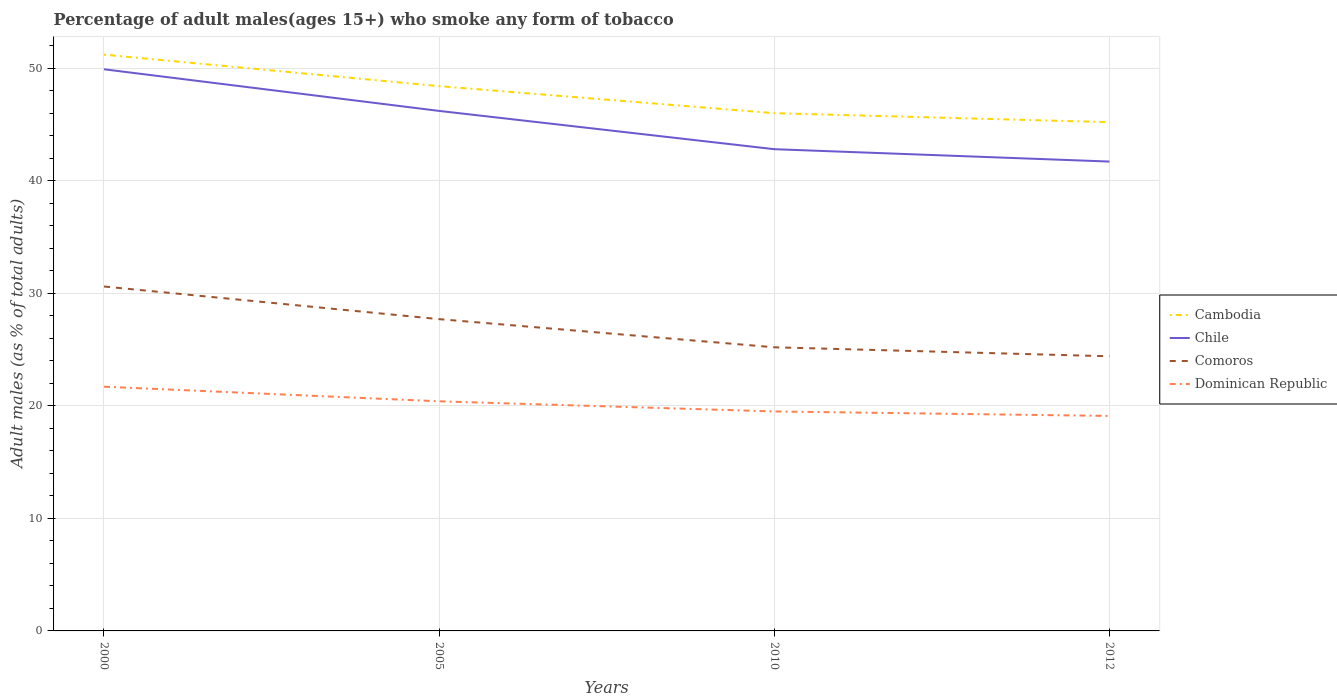How many different coloured lines are there?
Provide a succinct answer. 4. Across all years, what is the maximum percentage of adult males who smoke in Cambodia?
Offer a very short reply. 45.2. In which year was the percentage of adult males who smoke in Dominican Republic maximum?
Provide a succinct answer. 2012. What is the total percentage of adult males who smoke in Comoros in the graph?
Make the answer very short. 2.9. What is the difference between the highest and the second highest percentage of adult males who smoke in Cambodia?
Your response must be concise. 6. Is the percentage of adult males who smoke in Comoros strictly greater than the percentage of adult males who smoke in Cambodia over the years?
Provide a succinct answer. Yes. How many lines are there?
Your answer should be very brief. 4. How many years are there in the graph?
Your response must be concise. 4. What is the difference between two consecutive major ticks on the Y-axis?
Your answer should be compact. 10. Does the graph contain any zero values?
Your answer should be compact. No. Where does the legend appear in the graph?
Your answer should be compact. Center right. How are the legend labels stacked?
Keep it short and to the point. Vertical. What is the title of the graph?
Your answer should be very brief. Percentage of adult males(ages 15+) who smoke any form of tobacco. What is the label or title of the Y-axis?
Give a very brief answer. Adult males (as % of total adults). What is the Adult males (as % of total adults) of Cambodia in 2000?
Keep it short and to the point. 51.2. What is the Adult males (as % of total adults) of Chile in 2000?
Make the answer very short. 49.9. What is the Adult males (as % of total adults) of Comoros in 2000?
Provide a short and direct response. 30.6. What is the Adult males (as % of total adults) of Dominican Republic in 2000?
Make the answer very short. 21.7. What is the Adult males (as % of total adults) in Cambodia in 2005?
Your answer should be very brief. 48.4. What is the Adult males (as % of total adults) of Chile in 2005?
Offer a very short reply. 46.2. What is the Adult males (as % of total adults) in Comoros in 2005?
Provide a short and direct response. 27.7. What is the Adult males (as % of total adults) in Dominican Republic in 2005?
Your answer should be very brief. 20.4. What is the Adult males (as % of total adults) of Chile in 2010?
Give a very brief answer. 42.8. What is the Adult males (as % of total adults) in Comoros in 2010?
Provide a succinct answer. 25.2. What is the Adult males (as % of total adults) of Cambodia in 2012?
Offer a very short reply. 45.2. What is the Adult males (as % of total adults) of Chile in 2012?
Keep it short and to the point. 41.7. What is the Adult males (as % of total adults) in Comoros in 2012?
Offer a terse response. 24.4. Across all years, what is the maximum Adult males (as % of total adults) in Cambodia?
Provide a short and direct response. 51.2. Across all years, what is the maximum Adult males (as % of total adults) of Chile?
Give a very brief answer. 49.9. Across all years, what is the maximum Adult males (as % of total adults) in Comoros?
Give a very brief answer. 30.6. Across all years, what is the maximum Adult males (as % of total adults) in Dominican Republic?
Ensure brevity in your answer.  21.7. Across all years, what is the minimum Adult males (as % of total adults) in Cambodia?
Provide a succinct answer. 45.2. Across all years, what is the minimum Adult males (as % of total adults) in Chile?
Ensure brevity in your answer.  41.7. Across all years, what is the minimum Adult males (as % of total adults) of Comoros?
Your answer should be very brief. 24.4. What is the total Adult males (as % of total adults) in Cambodia in the graph?
Give a very brief answer. 190.8. What is the total Adult males (as % of total adults) in Chile in the graph?
Your response must be concise. 180.6. What is the total Adult males (as % of total adults) in Comoros in the graph?
Give a very brief answer. 107.9. What is the total Adult males (as % of total adults) of Dominican Republic in the graph?
Keep it short and to the point. 80.7. What is the difference between the Adult males (as % of total adults) of Chile in 2000 and that in 2005?
Make the answer very short. 3.7. What is the difference between the Adult males (as % of total adults) in Comoros in 2000 and that in 2005?
Offer a very short reply. 2.9. What is the difference between the Adult males (as % of total adults) in Cambodia in 2000 and that in 2010?
Your answer should be compact. 5.2. What is the difference between the Adult males (as % of total adults) of Chile in 2000 and that in 2010?
Provide a succinct answer. 7.1. What is the difference between the Adult males (as % of total adults) of Comoros in 2000 and that in 2010?
Your answer should be very brief. 5.4. What is the difference between the Adult males (as % of total adults) of Dominican Republic in 2000 and that in 2010?
Give a very brief answer. 2.2. What is the difference between the Adult males (as % of total adults) in Chile in 2000 and that in 2012?
Keep it short and to the point. 8.2. What is the difference between the Adult males (as % of total adults) in Dominican Republic in 2000 and that in 2012?
Make the answer very short. 2.6. What is the difference between the Adult males (as % of total adults) in Comoros in 2005 and that in 2010?
Offer a terse response. 2.5. What is the difference between the Adult males (as % of total adults) in Cambodia in 2005 and that in 2012?
Offer a terse response. 3.2. What is the difference between the Adult males (as % of total adults) of Dominican Republic in 2010 and that in 2012?
Offer a terse response. 0.4. What is the difference between the Adult males (as % of total adults) of Cambodia in 2000 and the Adult males (as % of total adults) of Chile in 2005?
Ensure brevity in your answer.  5. What is the difference between the Adult males (as % of total adults) of Cambodia in 2000 and the Adult males (as % of total adults) of Comoros in 2005?
Your answer should be compact. 23.5. What is the difference between the Adult males (as % of total adults) of Cambodia in 2000 and the Adult males (as % of total adults) of Dominican Republic in 2005?
Your answer should be very brief. 30.8. What is the difference between the Adult males (as % of total adults) in Chile in 2000 and the Adult males (as % of total adults) in Dominican Republic in 2005?
Provide a short and direct response. 29.5. What is the difference between the Adult males (as % of total adults) in Cambodia in 2000 and the Adult males (as % of total adults) in Dominican Republic in 2010?
Offer a terse response. 31.7. What is the difference between the Adult males (as % of total adults) of Chile in 2000 and the Adult males (as % of total adults) of Comoros in 2010?
Provide a succinct answer. 24.7. What is the difference between the Adult males (as % of total adults) in Chile in 2000 and the Adult males (as % of total adults) in Dominican Republic in 2010?
Provide a succinct answer. 30.4. What is the difference between the Adult males (as % of total adults) in Comoros in 2000 and the Adult males (as % of total adults) in Dominican Republic in 2010?
Offer a very short reply. 11.1. What is the difference between the Adult males (as % of total adults) in Cambodia in 2000 and the Adult males (as % of total adults) in Comoros in 2012?
Provide a succinct answer. 26.8. What is the difference between the Adult males (as % of total adults) of Cambodia in 2000 and the Adult males (as % of total adults) of Dominican Republic in 2012?
Provide a short and direct response. 32.1. What is the difference between the Adult males (as % of total adults) in Chile in 2000 and the Adult males (as % of total adults) in Dominican Republic in 2012?
Ensure brevity in your answer.  30.8. What is the difference between the Adult males (as % of total adults) of Comoros in 2000 and the Adult males (as % of total adults) of Dominican Republic in 2012?
Provide a short and direct response. 11.5. What is the difference between the Adult males (as % of total adults) of Cambodia in 2005 and the Adult males (as % of total adults) of Comoros in 2010?
Keep it short and to the point. 23.2. What is the difference between the Adult males (as % of total adults) in Cambodia in 2005 and the Adult males (as % of total adults) in Dominican Republic in 2010?
Keep it short and to the point. 28.9. What is the difference between the Adult males (as % of total adults) in Chile in 2005 and the Adult males (as % of total adults) in Comoros in 2010?
Offer a very short reply. 21. What is the difference between the Adult males (as % of total adults) of Chile in 2005 and the Adult males (as % of total adults) of Dominican Republic in 2010?
Give a very brief answer. 26.7. What is the difference between the Adult males (as % of total adults) of Comoros in 2005 and the Adult males (as % of total adults) of Dominican Republic in 2010?
Offer a terse response. 8.2. What is the difference between the Adult males (as % of total adults) of Cambodia in 2005 and the Adult males (as % of total adults) of Chile in 2012?
Your answer should be very brief. 6.7. What is the difference between the Adult males (as % of total adults) in Cambodia in 2005 and the Adult males (as % of total adults) in Dominican Republic in 2012?
Ensure brevity in your answer.  29.3. What is the difference between the Adult males (as % of total adults) of Chile in 2005 and the Adult males (as % of total adults) of Comoros in 2012?
Your answer should be compact. 21.8. What is the difference between the Adult males (as % of total adults) in Chile in 2005 and the Adult males (as % of total adults) in Dominican Republic in 2012?
Offer a very short reply. 27.1. What is the difference between the Adult males (as % of total adults) in Cambodia in 2010 and the Adult males (as % of total adults) in Chile in 2012?
Offer a very short reply. 4.3. What is the difference between the Adult males (as % of total adults) in Cambodia in 2010 and the Adult males (as % of total adults) in Comoros in 2012?
Make the answer very short. 21.6. What is the difference between the Adult males (as % of total adults) of Cambodia in 2010 and the Adult males (as % of total adults) of Dominican Republic in 2012?
Your response must be concise. 26.9. What is the difference between the Adult males (as % of total adults) of Chile in 2010 and the Adult males (as % of total adults) of Dominican Republic in 2012?
Offer a terse response. 23.7. What is the average Adult males (as % of total adults) in Cambodia per year?
Provide a short and direct response. 47.7. What is the average Adult males (as % of total adults) in Chile per year?
Offer a very short reply. 45.15. What is the average Adult males (as % of total adults) of Comoros per year?
Your answer should be very brief. 26.98. What is the average Adult males (as % of total adults) of Dominican Republic per year?
Offer a very short reply. 20.18. In the year 2000, what is the difference between the Adult males (as % of total adults) of Cambodia and Adult males (as % of total adults) of Comoros?
Your response must be concise. 20.6. In the year 2000, what is the difference between the Adult males (as % of total adults) in Cambodia and Adult males (as % of total adults) in Dominican Republic?
Ensure brevity in your answer.  29.5. In the year 2000, what is the difference between the Adult males (as % of total adults) in Chile and Adult males (as % of total adults) in Comoros?
Your response must be concise. 19.3. In the year 2000, what is the difference between the Adult males (as % of total adults) in Chile and Adult males (as % of total adults) in Dominican Republic?
Offer a terse response. 28.2. In the year 2005, what is the difference between the Adult males (as % of total adults) in Cambodia and Adult males (as % of total adults) in Chile?
Keep it short and to the point. 2.2. In the year 2005, what is the difference between the Adult males (as % of total adults) in Cambodia and Adult males (as % of total adults) in Comoros?
Make the answer very short. 20.7. In the year 2005, what is the difference between the Adult males (as % of total adults) of Cambodia and Adult males (as % of total adults) of Dominican Republic?
Provide a succinct answer. 28. In the year 2005, what is the difference between the Adult males (as % of total adults) of Chile and Adult males (as % of total adults) of Comoros?
Your response must be concise. 18.5. In the year 2005, what is the difference between the Adult males (as % of total adults) of Chile and Adult males (as % of total adults) of Dominican Republic?
Your response must be concise. 25.8. In the year 2005, what is the difference between the Adult males (as % of total adults) in Comoros and Adult males (as % of total adults) in Dominican Republic?
Your answer should be very brief. 7.3. In the year 2010, what is the difference between the Adult males (as % of total adults) of Cambodia and Adult males (as % of total adults) of Comoros?
Offer a terse response. 20.8. In the year 2010, what is the difference between the Adult males (as % of total adults) in Cambodia and Adult males (as % of total adults) in Dominican Republic?
Keep it short and to the point. 26.5. In the year 2010, what is the difference between the Adult males (as % of total adults) in Chile and Adult males (as % of total adults) in Dominican Republic?
Offer a very short reply. 23.3. In the year 2010, what is the difference between the Adult males (as % of total adults) of Comoros and Adult males (as % of total adults) of Dominican Republic?
Provide a short and direct response. 5.7. In the year 2012, what is the difference between the Adult males (as % of total adults) of Cambodia and Adult males (as % of total adults) of Chile?
Your response must be concise. 3.5. In the year 2012, what is the difference between the Adult males (as % of total adults) of Cambodia and Adult males (as % of total adults) of Comoros?
Keep it short and to the point. 20.8. In the year 2012, what is the difference between the Adult males (as % of total adults) in Cambodia and Adult males (as % of total adults) in Dominican Republic?
Give a very brief answer. 26.1. In the year 2012, what is the difference between the Adult males (as % of total adults) in Chile and Adult males (as % of total adults) in Dominican Republic?
Your answer should be compact. 22.6. What is the ratio of the Adult males (as % of total adults) of Cambodia in 2000 to that in 2005?
Offer a very short reply. 1.06. What is the ratio of the Adult males (as % of total adults) of Chile in 2000 to that in 2005?
Ensure brevity in your answer.  1.08. What is the ratio of the Adult males (as % of total adults) of Comoros in 2000 to that in 2005?
Offer a terse response. 1.1. What is the ratio of the Adult males (as % of total adults) in Dominican Republic in 2000 to that in 2005?
Your answer should be compact. 1.06. What is the ratio of the Adult males (as % of total adults) of Cambodia in 2000 to that in 2010?
Give a very brief answer. 1.11. What is the ratio of the Adult males (as % of total adults) of Chile in 2000 to that in 2010?
Give a very brief answer. 1.17. What is the ratio of the Adult males (as % of total adults) of Comoros in 2000 to that in 2010?
Your answer should be compact. 1.21. What is the ratio of the Adult males (as % of total adults) in Dominican Republic in 2000 to that in 2010?
Offer a terse response. 1.11. What is the ratio of the Adult males (as % of total adults) of Cambodia in 2000 to that in 2012?
Keep it short and to the point. 1.13. What is the ratio of the Adult males (as % of total adults) in Chile in 2000 to that in 2012?
Offer a very short reply. 1.2. What is the ratio of the Adult males (as % of total adults) of Comoros in 2000 to that in 2012?
Provide a short and direct response. 1.25. What is the ratio of the Adult males (as % of total adults) of Dominican Republic in 2000 to that in 2012?
Your response must be concise. 1.14. What is the ratio of the Adult males (as % of total adults) of Cambodia in 2005 to that in 2010?
Keep it short and to the point. 1.05. What is the ratio of the Adult males (as % of total adults) in Chile in 2005 to that in 2010?
Your response must be concise. 1.08. What is the ratio of the Adult males (as % of total adults) of Comoros in 2005 to that in 2010?
Your answer should be compact. 1.1. What is the ratio of the Adult males (as % of total adults) of Dominican Republic in 2005 to that in 2010?
Give a very brief answer. 1.05. What is the ratio of the Adult males (as % of total adults) in Cambodia in 2005 to that in 2012?
Offer a very short reply. 1.07. What is the ratio of the Adult males (as % of total adults) of Chile in 2005 to that in 2012?
Ensure brevity in your answer.  1.11. What is the ratio of the Adult males (as % of total adults) of Comoros in 2005 to that in 2012?
Ensure brevity in your answer.  1.14. What is the ratio of the Adult males (as % of total adults) of Dominican Republic in 2005 to that in 2012?
Provide a succinct answer. 1.07. What is the ratio of the Adult males (as % of total adults) in Cambodia in 2010 to that in 2012?
Ensure brevity in your answer.  1.02. What is the ratio of the Adult males (as % of total adults) of Chile in 2010 to that in 2012?
Ensure brevity in your answer.  1.03. What is the ratio of the Adult males (as % of total adults) of Comoros in 2010 to that in 2012?
Offer a very short reply. 1.03. What is the ratio of the Adult males (as % of total adults) in Dominican Republic in 2010 to that in 2012?
Keep it short and to the point. 1.02. What is the difference between the highest and the second highest Adult males (as % of total adults) in Comoros?
Offer a terse response. 2.9. What is the difference between the highest and the lowest Adult males (as % of total adults) in Cambodia?
Offer a terse response. 6. What is the difference between the highest and the lowest Adult males (as % of total adults) of Chile?
Make the answer very short. 8.2. 